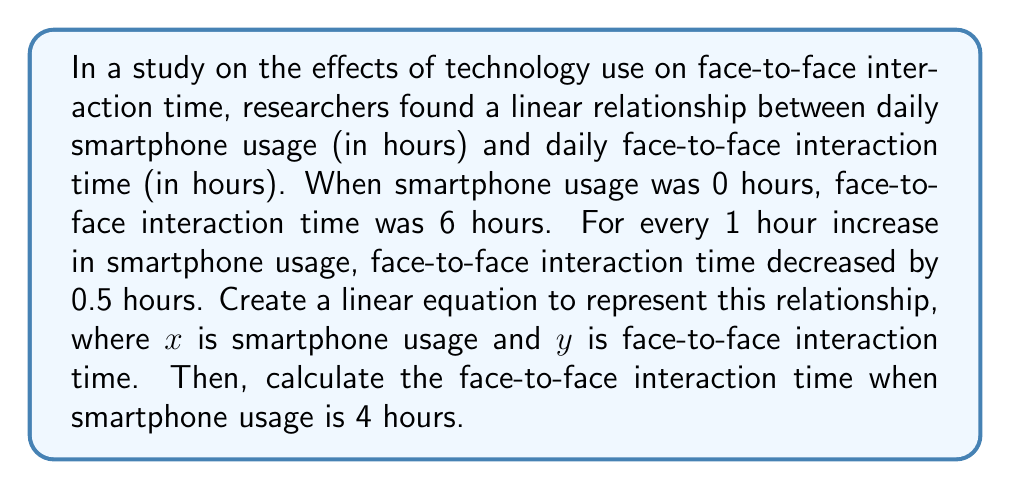Can you answer this question? 1. Identify the slope and y-intercept:
   - y-intercept (b): When smartphone usage is 0, face-to-face interaction is 6 hours. So, $b = 6$.
   - Slope (m): For every 1 hour increase in smartphone usage, face-to-face interaction decreases by 0.5 hours. So, $m = -0.5$.

2. Use the slope-intercept form of a linear equation: $y = mx + b$

3. Substitute the values:
   $y = -0.5x + 6$

4. To find face-to-face interaction time when smartphone usage is 4 hours, substitute $x = 4$:
   $y = -0.5(4) + 6$
   $y = -2 + 6$
   $y = 4$

Therefore, when smartphone usage is 4 hours, face-to-face interaction time is 4 hours.
Answer: $y = -0.5x + 6$; 4 hours 